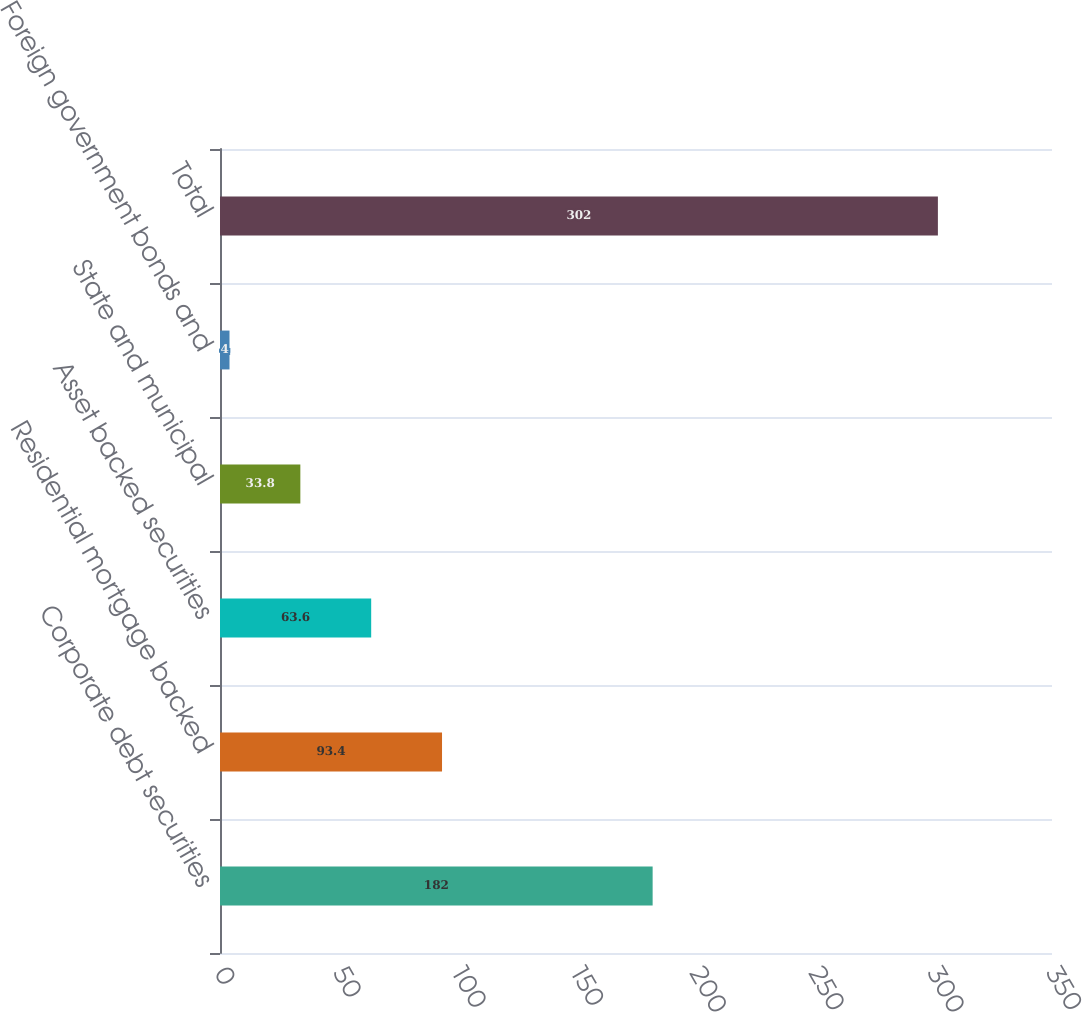Convert chart to OTSL. <chart><loc_0><loc_0><loc_500><loc_500><bar_chart><fcel>Corporate debt securities<fcel>Residential mortgage backed<fcel>Asset backed securities<fcel>State and municipal<fcel>Foreign government bonds and<fcel>Total<nl><fcel>182<fcel>93.4<fcel>63.6<fcel>33.8<fcel>4<fcel>302<nl></chart> 